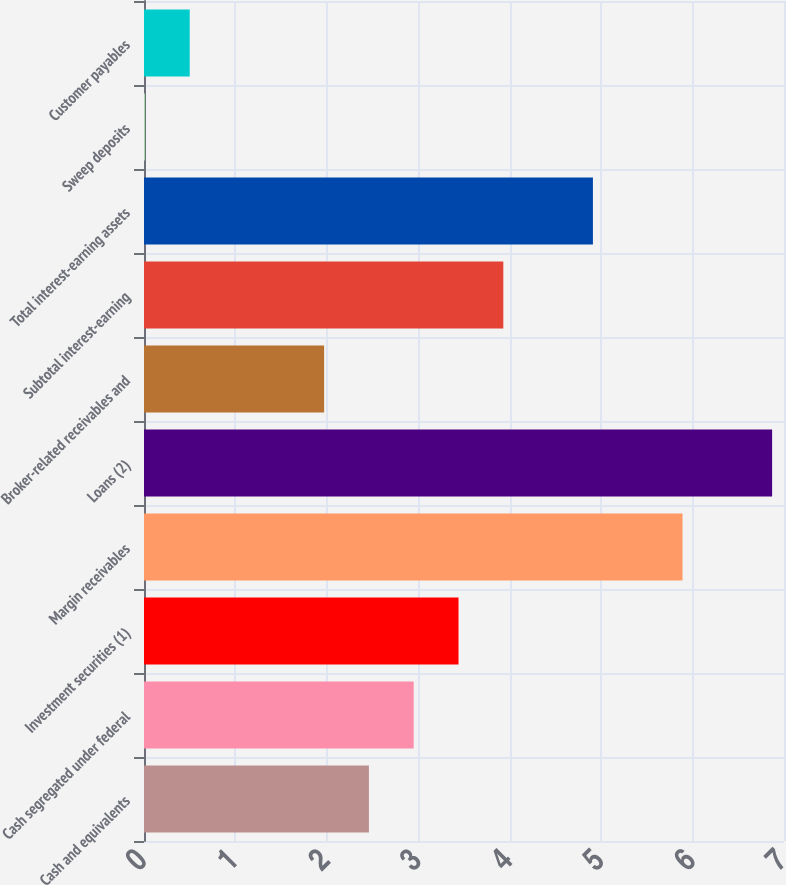Convert chart to OTSL. <chart><loc_0><loc_0><loc_500><loc_500><bar_chart><fcel>Cash and equivalents<fcel>Cash segregated under federal<fcel>Investment securities (1)<fcel>Margin receivables<fcel>Loans (2)<fcel>Broker-related receivables and<fcel>Subtotal interest-earning<fcel>Total interest-earning assets<fcel>Sweep deposits<fcel>Customer payables<nl><fcel>2.46<fcel>2.95<fcel>3.44<fcel>5.89<fcel>6.87<fcel>1.97<fcel>3.93<fcel>4.91<fcel>0.01<fcel>0.5<nl></chart> 